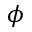Convert formula to latex. <formula><loc_0><loc_0><loc_500><loc_500>\phi</formula> 